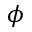Convert formula to latex. <formula><loc_0><loc_0><loc_500><loc_500>\phi</formula> 